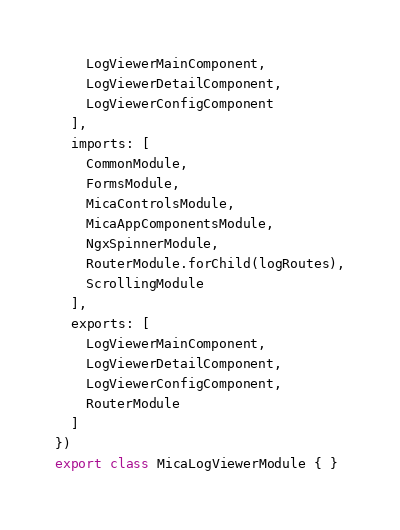Convert code to text. <code><loc_0><loc_0><loc_500><loc_500><_TypeScript_>    LogViewerMainComponent,
    LogViewerDetailComponent,
    LogViewerConfigComponent
  ],
  imports: [
    CommonModule,
    FormsModule,
    MicaControlsModule,
    MicaAppComponentsModule,
    NgxSpinnerModule,
    RouterModule.forChild(logRoutes),
    ScrollingModule
  ],
  exports: [
    LogViewerMainComponent,
    LogViewerDetailComponent,
    LogViewerConfigComponent,
    RouterModule
  ]
})
export class MicaLogViewerModule { }
</code> 